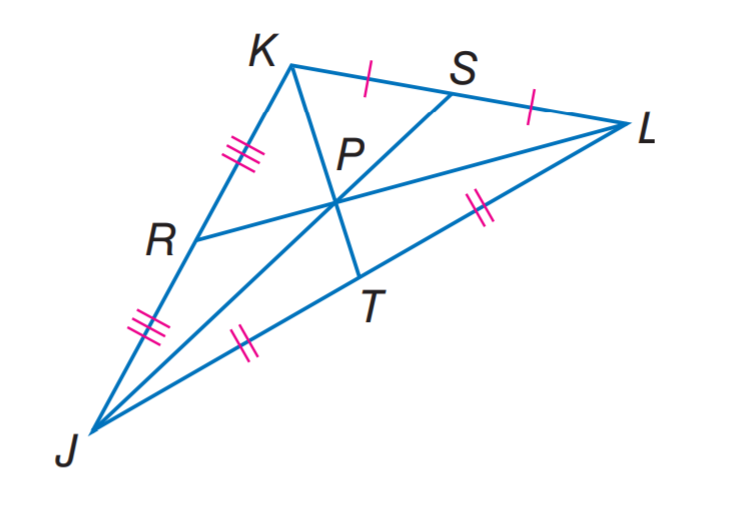Answer the mathemtical geometry problem and directly provide the correct option letter.
Question: R P = 3.5 and J P = 9. Find P S.
Choices: A: 3.5 B: 4.5 C: 7 D: 9 B 